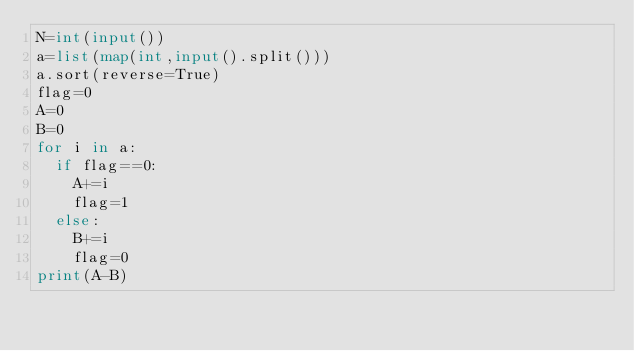Convert code to text. <code><loc_0><loc_0><loc_500><loc_500><_Python_>N=int(input())
a=list(map(int,input().split()))
a.sort(reverse=True)
flag=0
A=0
B=0
for i in a:
  if flag==0:
    A+=i
    flag=1
  else:
    B+=i
    flag=0
print(A-B)</code> 